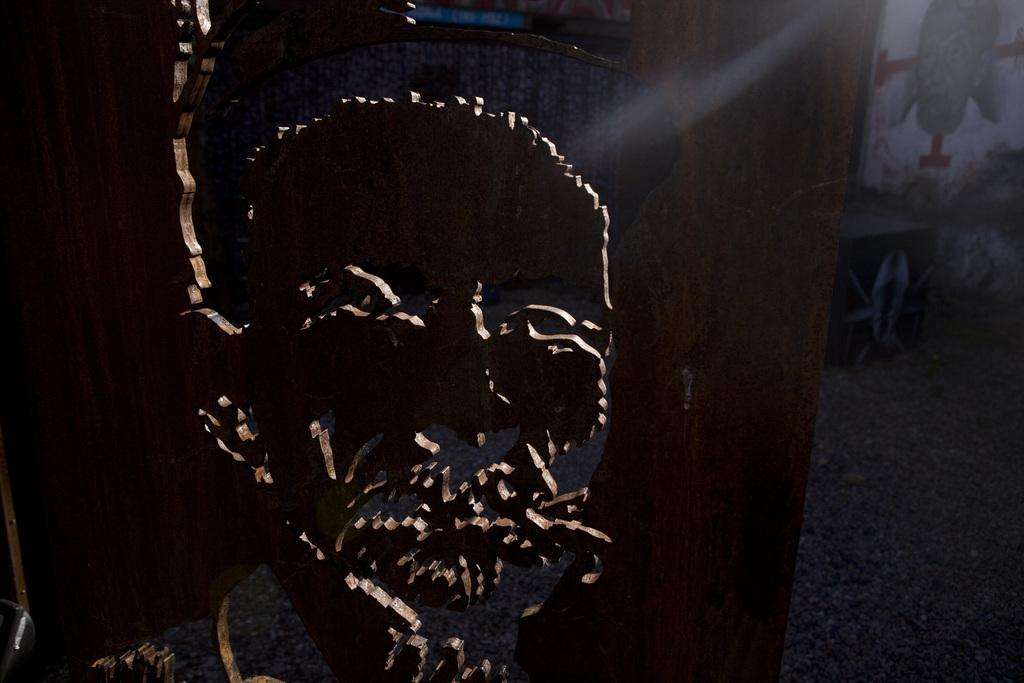What is the main object in the image? There is a wooden board in the image. What is depicted on the wooden board? A face of a person is carved on the wooden board. What is located to the right of the wooden board? There is a wall to the right of the wooden board. What can be seen on the wall? There is a painting of a person on the wall. What type of metal arch can be seen in the image? There is no metal arch present in the image. Can you describe the stranger in the image? There is no stranger depicted in the image; it features a wooden board with a carved face and a painting of a person on the wall. 